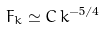<formula> <loc_0><loc_0><loc_500><loc_500>F _ { k } \simeq C \, k ^ { - 5 / 4 }</formula> 